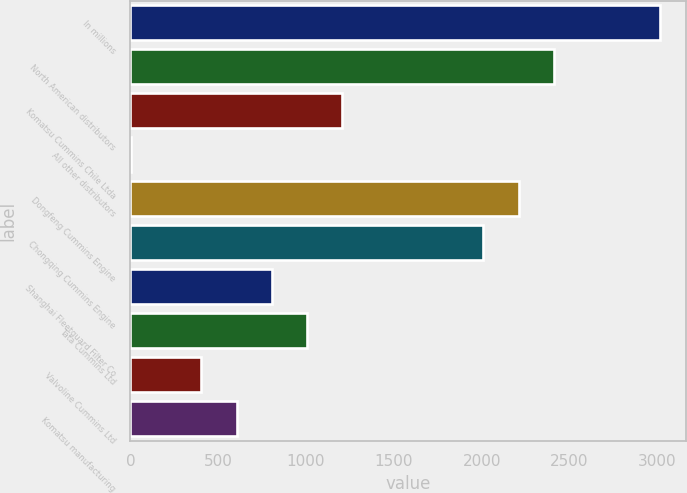Convert chart to OTSL. <chart><loc_0><loc_0><loc_500><loc_500><bar_chart><fcel>In millions<fcel>North American distributors<fcel>Komatsu Cummins Chile Ltda<fcel>All other distributors<fcel>Dongfeng Cummins Engine<fcel>Chongqing Cummins Engine<fcel>Shanghai Fleetguard Filter Co<fcel>Tata Cummins Ltd<fcel>Valvoline Cummins Ltd<fcel>Komatsu manufacturing<nl><fcel>3013.5<fcel>2411.4<fcel>1207.2<fcel>3<fcel>2210.7<fcel>2010<fcel>805.8<fcel>1006.5<fcel>404.4<fcel>605.1<nl></chart> 